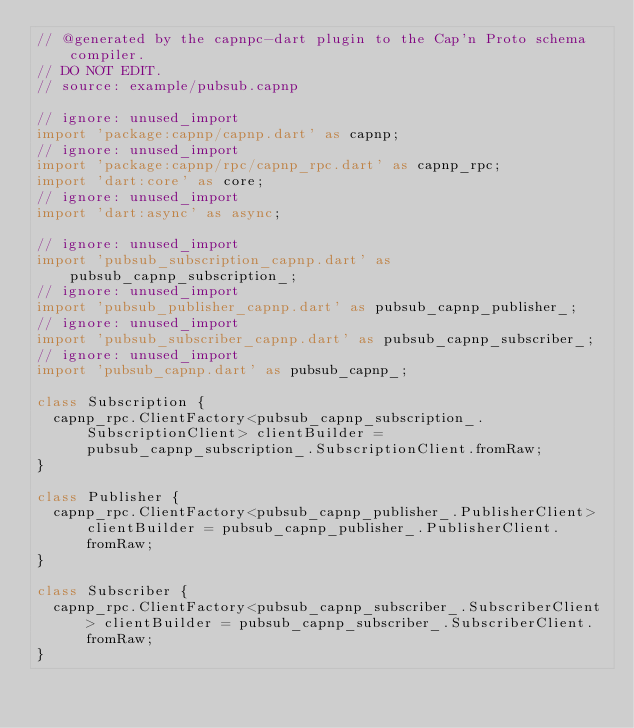<code> <loc_0><loc_0><loc_500><loc_500><_Dart_>// @generated by the capnpc-dart plugin to the Cap'n Proto schema compiler.
// DO NOT EDIT.
// source: example/pubsub.capnp

// ignore: unused_import
import 'package:capnp/capnp.dart' as capnp;
// ignore: unused_import
import 'package:capnp/rpc/capnp_rpc.dart' as capnp_rpc;
import 'dart:core' as core;
// ignore: unused_import
import 'dart:async' as async;

// ignore: unused_import
import 'pubsub_subscription_capnp.dart' as pubsub_capnp_subscription_;
// ignore: unused_import
import 'pubsub_publisher_capnp.dart' as pubsub_capnp_publisher_;
// ignore: unused_import
import 'pubsub_subscriber_capnp.dart' as pubsub_capnp_subscriber_;
// ignore: unused_import
import 'pubsub_capnp.dart' as pubsub_capnp_;

class Subscription {
  capnp_rpc.ClientFactory<pubsub_capnp_subscription_.SubscriptionClient> clientBuilder = pubsub_capnp_subscription_.SubscriptionClient.fromRaw;
}

class Publisher {
  capnp_rpc.ClientFactory<pubsub_capnp_publisher_.PublisherClient> clientBuilder = pubsub_capnp_publisher_.PublisherClient.fromRaw;
}

class Subscriber {
  capnp_rpc.ClientFactory<pubsub_capnp_subscriber_.SubscriberClient> clientBuilder = pubsub_capnp_subscriber_.SubscriberClient.fromRaw;
}

</code> 